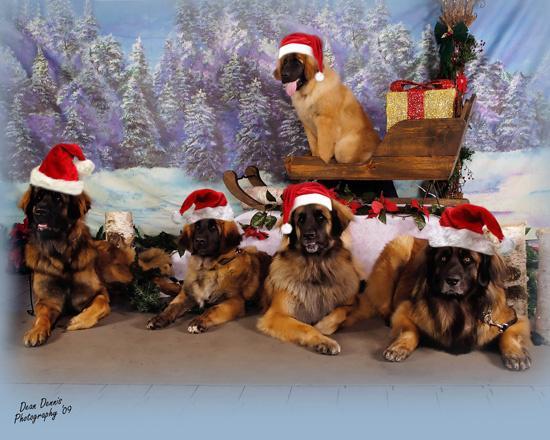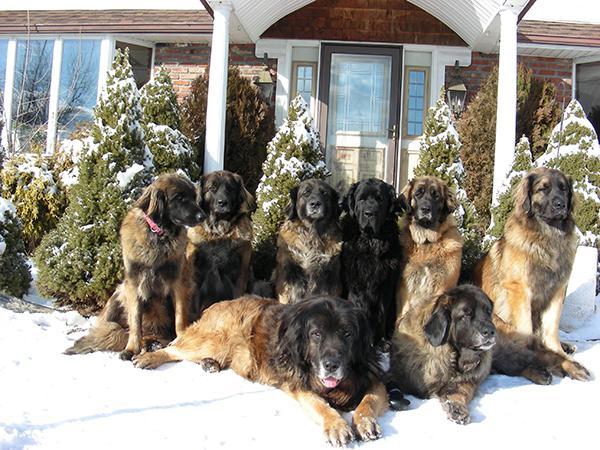The first image is the image on the left, the second image is the image on the right. Given the left and right images, does the statement "Santa-themed red and white attire is included in one image with at least one dog." hold true? Answer yes or no. Yes. The first image is the image on the left, the second image is the image on the right. Examine the images to the left and right. Is the description "Christmas decorations can be seen in one of the pictures." accurate? Answer yes or no. Yes. 